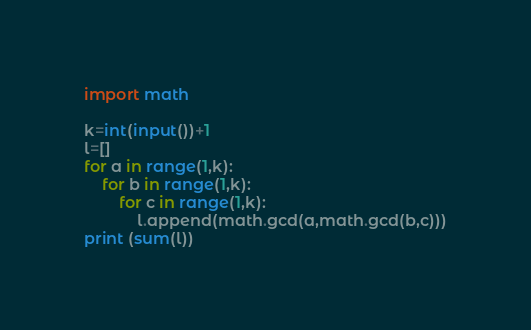<code> <loc_0><loc_0><loc_500><loc_500><_Python_>import math

k=int(input())+1
l=[]
for a in range(1,k):
    for b in range(1,k):
        for c in range(1,k):
            l.append(math.gcd(a,math.gcd(b,c)))
print (sum(l))</code> 